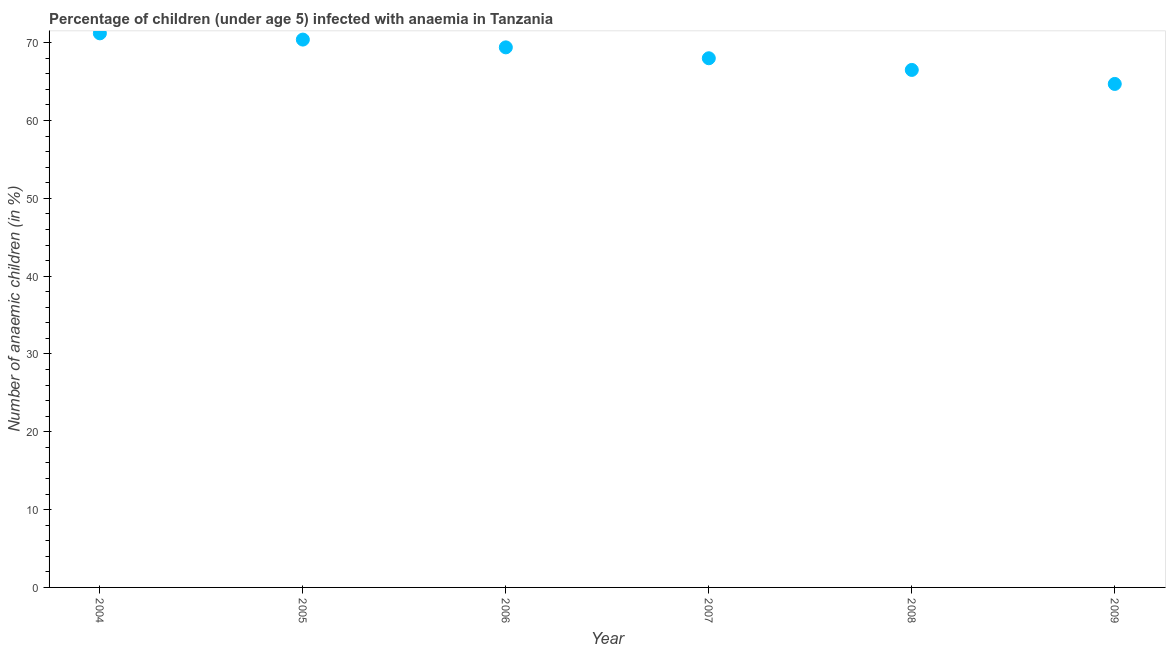What is the number of anaemic children in 2008?
Make the answer very short. 66.5. Across all years, what is the maximum number of anaemic children?
Your answer should be compact. 71.2. Across all years, what is the minimum number of anaemic children?
Provide a succinct answer. 64.7. In which year was the number of anaemic children minimum?
Provide a succinct answer. 2009. What is the sum of the number of anaemic children?
Offer a terse response. 410.2. What is the difference between the number of anaemic children in 2004 and 2009?
Provide a succinct answer. 6.5. What is the average number of anaemic children per year?
Ensure brevity in your answer.  68.37. What is the median number of anaemic children?
Your response must be concise. 68.7. Do a majority of the years between 2005 and 2007 (inclusive) have number of anaemic children greater than 58 %?
Give a very brief answer. Yes. What is the ratio of the number of anaemic children in 2004 to that in 2005?
Offer a terse response. 1.01. Is the number of anaemic children in 2005 less than that in 2008?
Make the answer very short. No. Is the difference between the number of anaemic children in 2005 and 2009 greater than the difference between any two years?
Provide a succinct answer. No. What is the difference between the highest and the second highest number of anaemic children?
Offer a very short reply. 0.8. Is the sum of the number of anaemic children in 2007 and 2009 greater than the maximum number of anaemic children across all years?
Ensure brevity in your answer.  Yes. In how many years, is the number of anaemic children greater than the average number of anaemic children taken over all years?
Offer a very short reply. 3. How many dotlines are there?
Provide a succinct answer. 1. How many years are there in the graph?
Keep it short and to the point. 6. What is the difference between two consecutive major ticks on the Y-axis?
Keep it short and to the point. 10. Does the graph contain grids?
Provide a short and direct response. No. What is the title of the graph?
Make the answer very short. Percentage of children (under age 5) infected with anaemia in Tanzania. What is the label or title of the X-axis?
Provide a short and direct response. Year. What is the label or title of the Y-axis?
Offer a terse response. Number of anaemic children (in %). What is the Number of anaemic children (in %) in 2004?
Provide a succinct answer. 71.2. What is the Number of anaemic children (in %) in 2005?
Provide a succinct answer. 70.4. What is the Number of anaemic children (in %) in 2006?
Give a very brief answer. 69.4. What is the Number of anaemic children (in %) in 2007?
Make the answer very short. 68. What is the Number of anaemic children (in %) in 2008?
Your answer should be very brief. 66.5. What is the Number of anaemic children (in %) in 2009?
Your answer should be compact. 64.7. What is the difference between the Number of anaemic children (in %) in 2004 and 2005?
Make the answer very short. 0.8. What is the difference between the Number of anaemic children (in %) in 2004 and 2006?
Ensure brevity in your answer.  1.8. What is the difference between the Number of anaemic children (in %) in 2005 and 2008?
Ensure brevity in your answer.  3.9. What is the difference between the Number of anaemic children (in %) in 2005 and 2009?
Your answer should be compact. 5.7. What is the difference between the Number of anaemic children (in %) in 2006 and 2008?
Ensure brevity in your answer.  2.9. What is the difference between the Number of anaemic children (in %) in 2007 and 2008?
Keep it short and to the point. 1.5. What is the difference between the Number of anaemic children (in %) in 2008 and 2009?
Offer a terse response. 1.8. What is the ratio of the Number of anaemic children (in %) in 2004 to that in 2005?
Provide a short and direct response. 1.01. What is the ratio of the Number of anaemic children (in %) in 2004 to that in 2007?
Keep it short and to the point. 1.05. What is the ratio of the Number of anaemic children (in %) in 2004 to that in 2008?
Your response must be concise. 1.07. What is the ratio of the Number of anaemic children (in %) in 2005 to that in 2007?
Provide a short and direct response. 1.03. What is the ratio of the Number of anaemic children (in %) in 2005 to that in 2008?
Provide a short and direct response. 1.06. What is the ratio of the Number of anaemic children (in %) in 2005 to that in 2009?
Provide a short and direct response. 1.09. What is the ratio of the Number of anaemic children (in %) in 2006 to that in 2008?
Make the answer very short. 1.04. What is the ratio of the Number of anaemic children (in %) in 2006 to that in 2009?
Your answer should be compact. 1.07. What is the ratio of the Number of anaemic children (in %) in 2007 to that in 2009?
Keep it short and to the point. 1.05. What is the ratio of the Number of anaemic children (in %) in 2008 to that in 2009?
Your response must be concise. 1.03. 